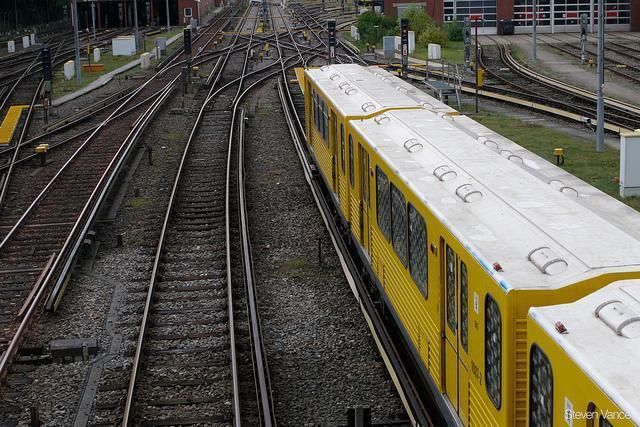How many people are there?
Give a very brief answer. 0. 